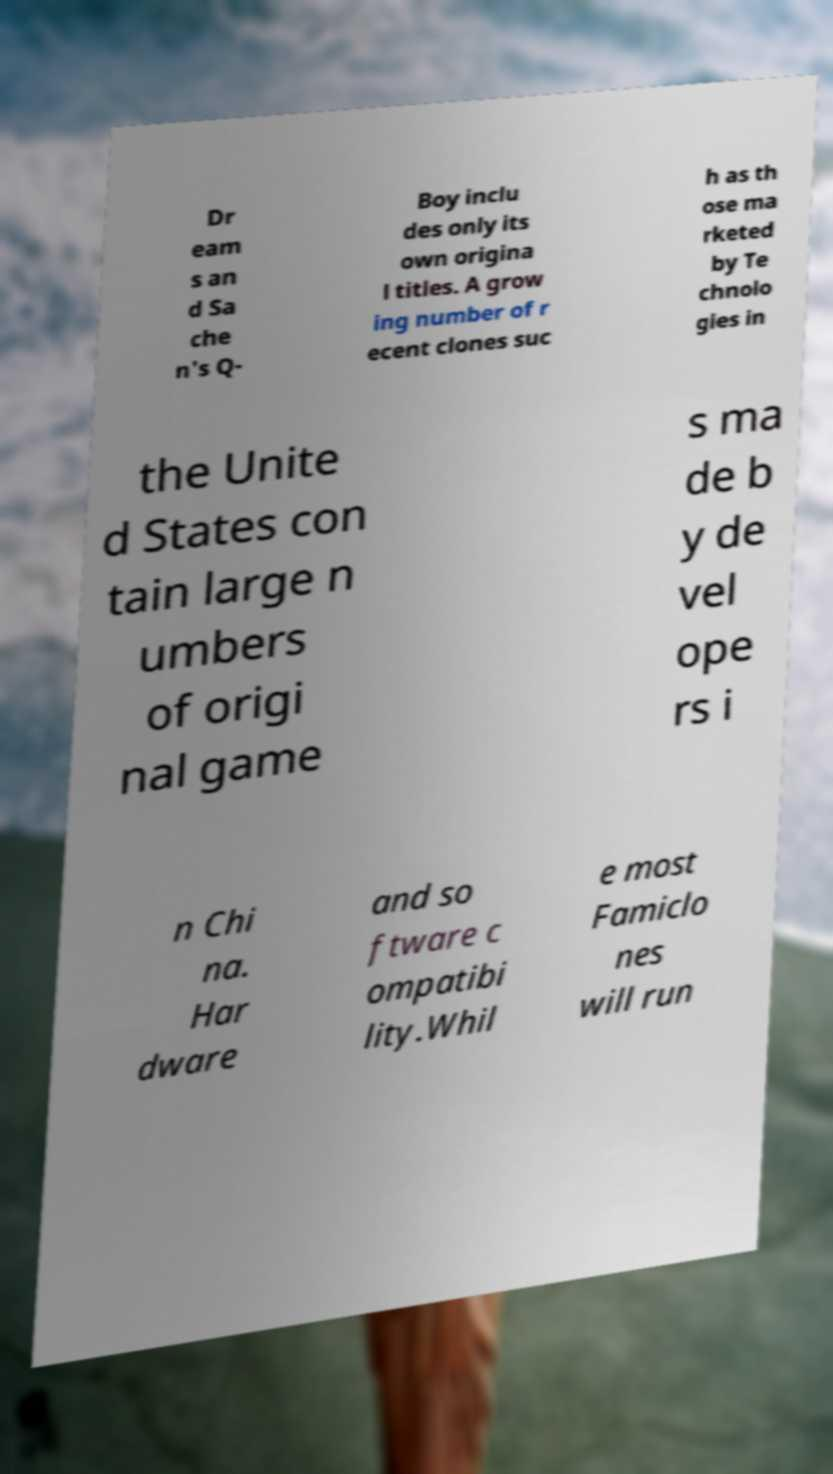Can you read and provide the text displayed in the image?This photo seems to have some interesting text. Can you extract and type it out for me? Dr eam s an d Sa che n's Q- Boy inclu des only its own origina l titles. A grow ing number of r ecent clones suc h as th ose ma rketed by Te chnolo gies in the Unite d States con tain large n umbers of origi nal game s ma de b y de vel ope rs i n Chi na. Har dware and so ftware c ompatibi lity.Whil e most Famiclo nes will run 